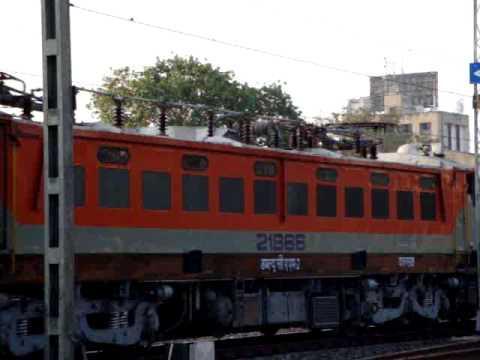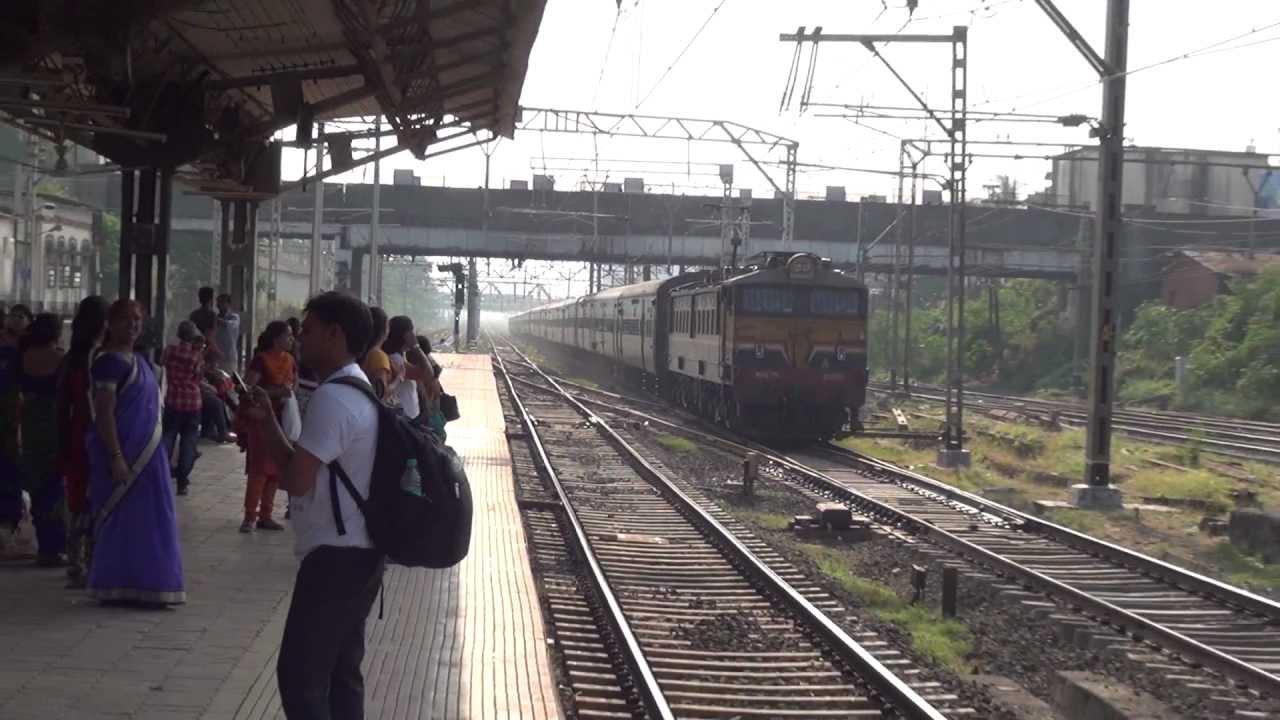The first image is the image on the left, the second image is the image on the right. Given the left and right images, does the statement "One of the trains is blue with a yellow stripe on it." hold true? Answer yes or no. No. The first image is the image on the left, the second image is the image on the right. Evaluate the accuracy of this statement regarding the images: "An image shows an angled baby-blue train with a yellow stripe, and above the train is a hinged metal contraption.". Is it true? Answer yes or no. No. 